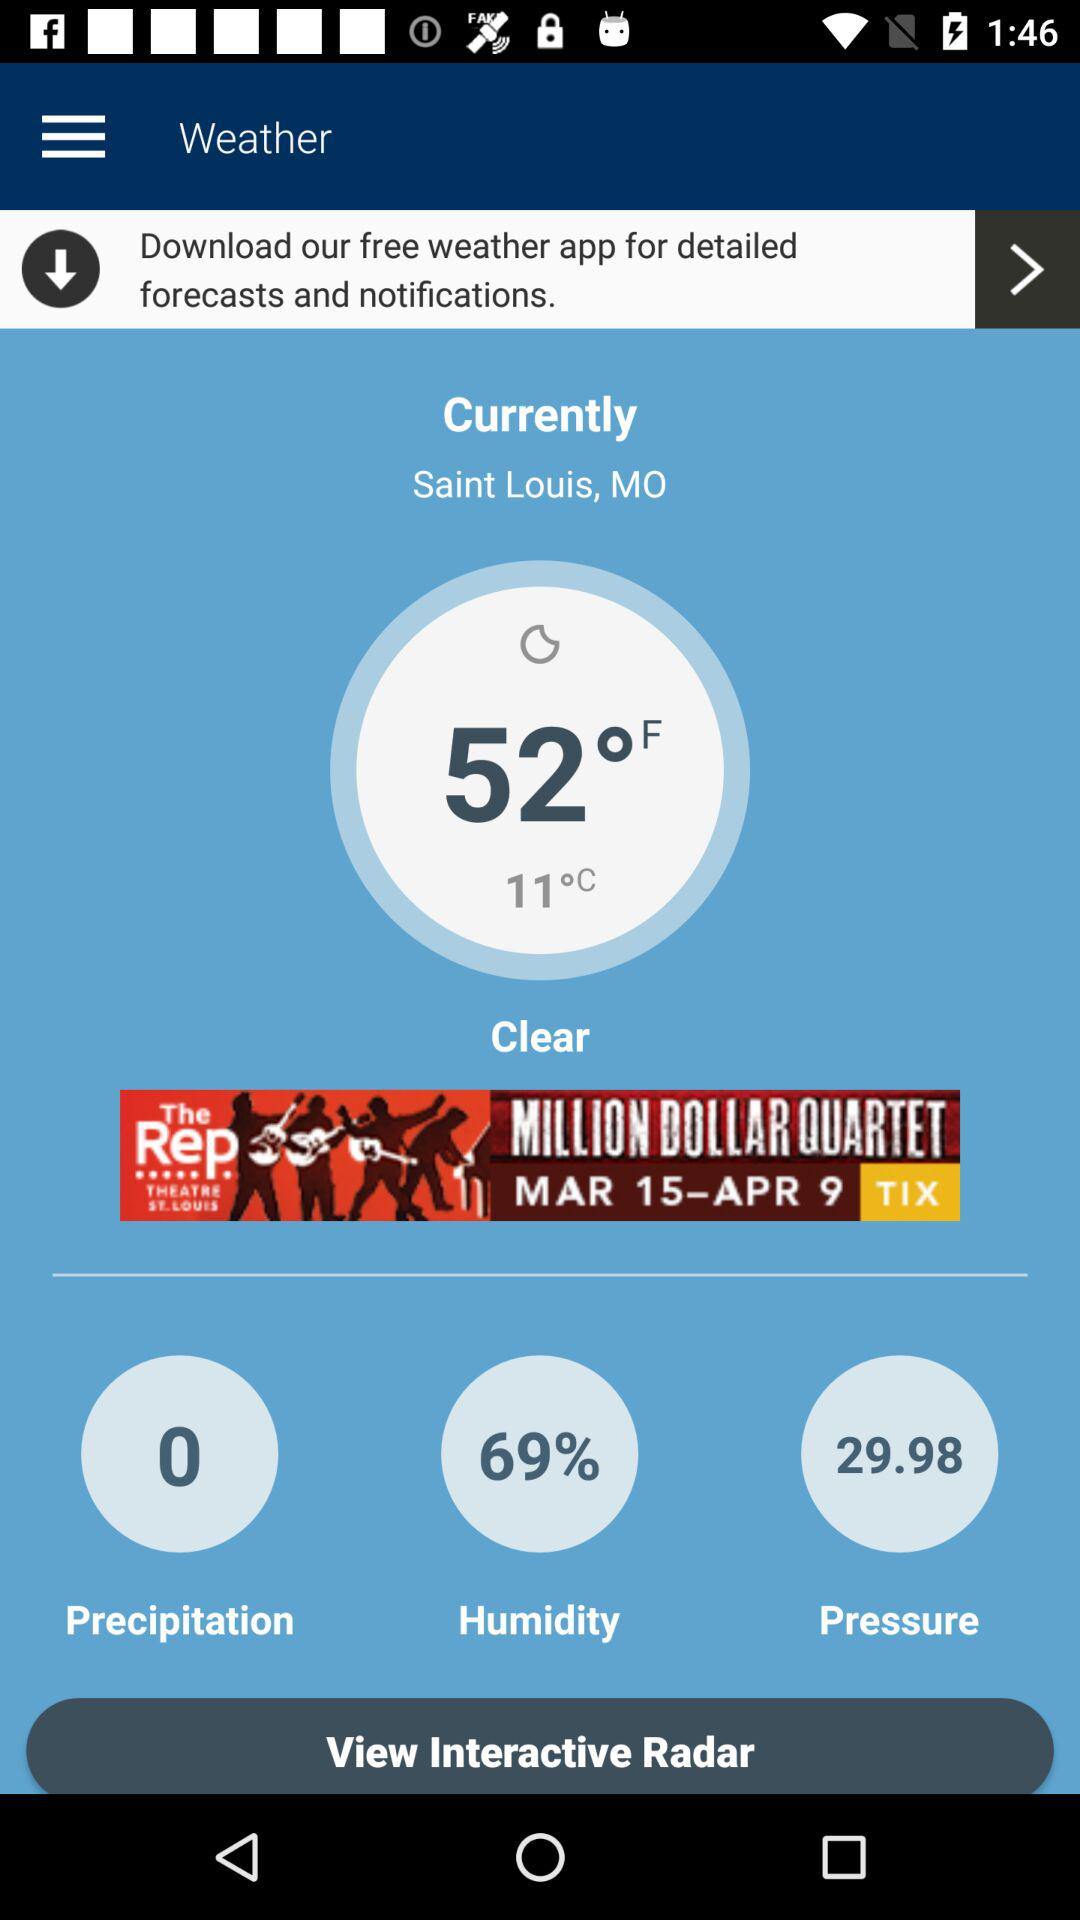What's the percentage of humidity? The percentage of humidity is 69. 